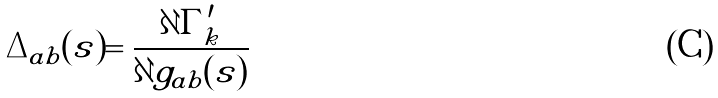Convert formula to latex. <formula><loc_0><loc_0><loc_500><loc_500>\Delta _ { a b } ( s ) = \frac { \partial \Gamma ^ { \prime } _ { k } } { \partial g _ { a b } ( s ) }</formula> 